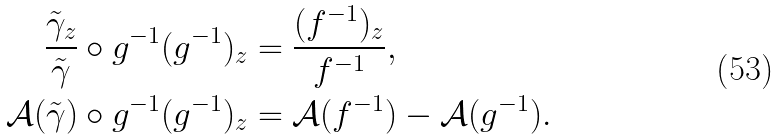<formula> <loc_0><loc_0><loc_500><loc_500>\frac { \tilde { \gamma } _ { z } } { \tilde { \gamma } } \circ g ^ { - 1 } ( g ^ { - 1 } ) _ { z } & = \frac { ( f ^ { - 1 } ) _ { z } } { f ^ { - 1 } } , \\ \mathcal { A } ( \tilde { \gamma } ) \circ g ^ { - 1 } ( g ^ { - 1 } ) _ { z } & = \mathcal { A } ( f ^ { - 1 } ) - \mathcal { A } ( g ^ { - 1 } ) .</formula> 